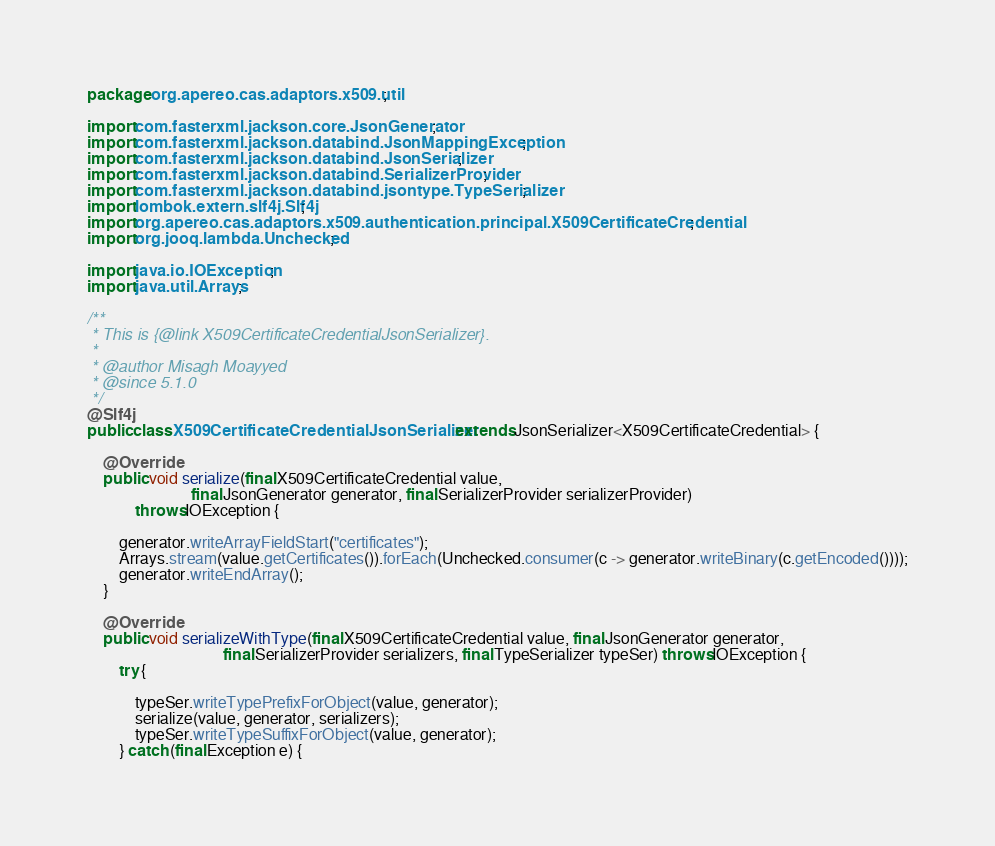Convert code to text. <code><loc_0><loc_0><loc_500><loc_500><_Java_>package org.apereo.cas.adaptors.x509.util;

import com.fasterxml.jackson.core.JsonGenerator;
import com.fasterxml.jackson.databind.JsonMappingException;
import com.fasterxml.jackson.databind.JsonSerializer;
import com.fasterxml.jackson.databind.SerializerProvider;
import com.fasterxml.jackson.databind.jsontype.TypeSerializer;
import lombok.extern.slf4j.Slf4j;
import org.apereo.cas.adaptors.x509.authentication.principal.X509CertificateCredential;
import org.jooq.lambda.Unchecked;

import java.io.IOException;
import java.util.Arrays;

/**
 * This is {@link X509CertificateCredentialJsonSerializer}.
 *
 * @author Misagh Moayyed
 * @since 5.1.0
 */
@Slf4j
public class X509CertificateCredentialJsonSerializer extends JsonSerializer<X509CertificateCredential> {

    @Override
    public void serialize(final X509CertificateCredential value, 
                          final JsonGenerator generator, final SerializerProvider serializerProvider) 
            throws IOException {

        generator.writeArrayFieldStart("certificates");
        Arrays.stream(value.getCertificates()).forEach(Unchecked.consumer(c -> generator.writeBinary(c.getEncoded())));
        generator.writeEndArray();
    }

    @Override
    public void serializeWithType(final X509CertificateCredential value, final JsonGenerator generator, 
                                  final SerializerProvider serializers, final TypeSerializer typeSer) throws IOException {
        try {

            typeSer.writeTypePrefixForObject(value, generator);
            serialize(value, generator, serializers); 
            typeSer.writeTypeSuffixForObject(value, generator);
        } catch (final Exception e) {</code> 